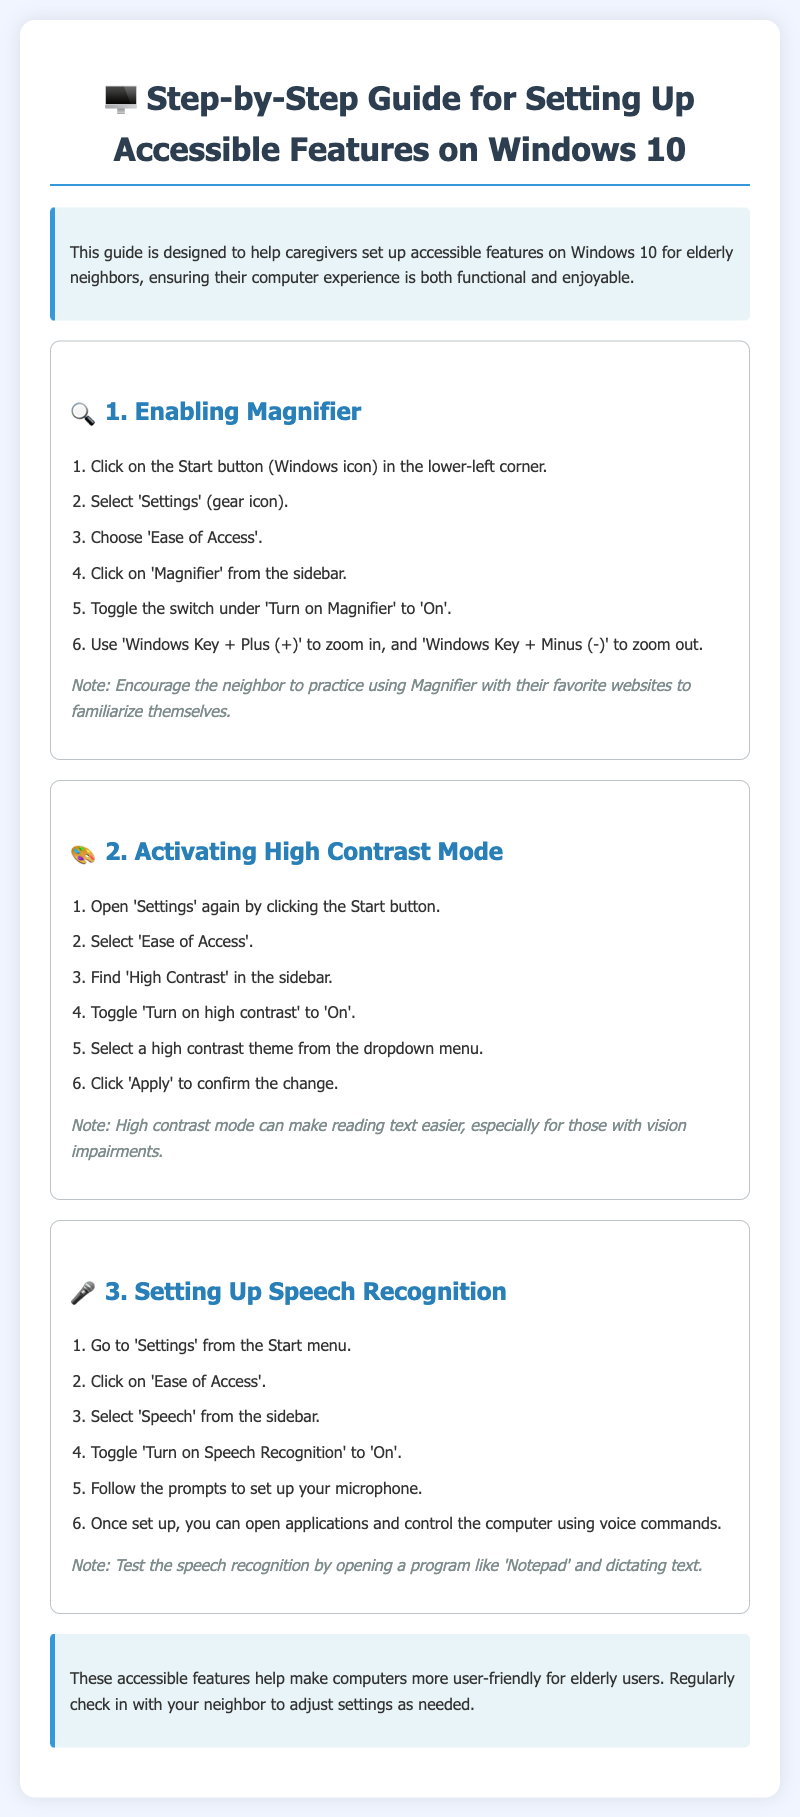What is the first step to enable Magnifier? The first step is to click on the Start button (Windows icon) in the lower-left corner.
Answer: Click on the Start button What color is the background of the guide? The background color of the guide is specified as #f0f5ff.
Answer: Light blue How many main features are covered in the guide? The guide covers three main features: Magnifier, High Contrast Mode, and Speech Recognition.
Answer: Three Which keyboard shortcut is used to zoom in with the Magnifier? The keyboard shortcut for zooming in is described as 'Windows Key + Plus (+)'.
Answer: Windows Key + Plus (+) What must be done after selecting a high contrast theme? After selecting a high contrast theme, you must click 'Apply' to confirm the change.
Answer: Click 'Apply' What is the purpose of the speech recognition setup? The purpose of the speech recognition setup is to allow users to open applications and control the computer using voice commands.
Answer: Voice commands Which section explains the activation of high contrast mode? The section that explains the activation of high contrast mode is titled "Activating High Contrast Mode."
Answer: Activating High Contrast Mode What is the last step in the Magnifier setup? The last step in the Magnifier setup is to use 'Windows Key + Minus (-)' to zoom out.
Answer: Use 'Windows Key + Minus (-)' 